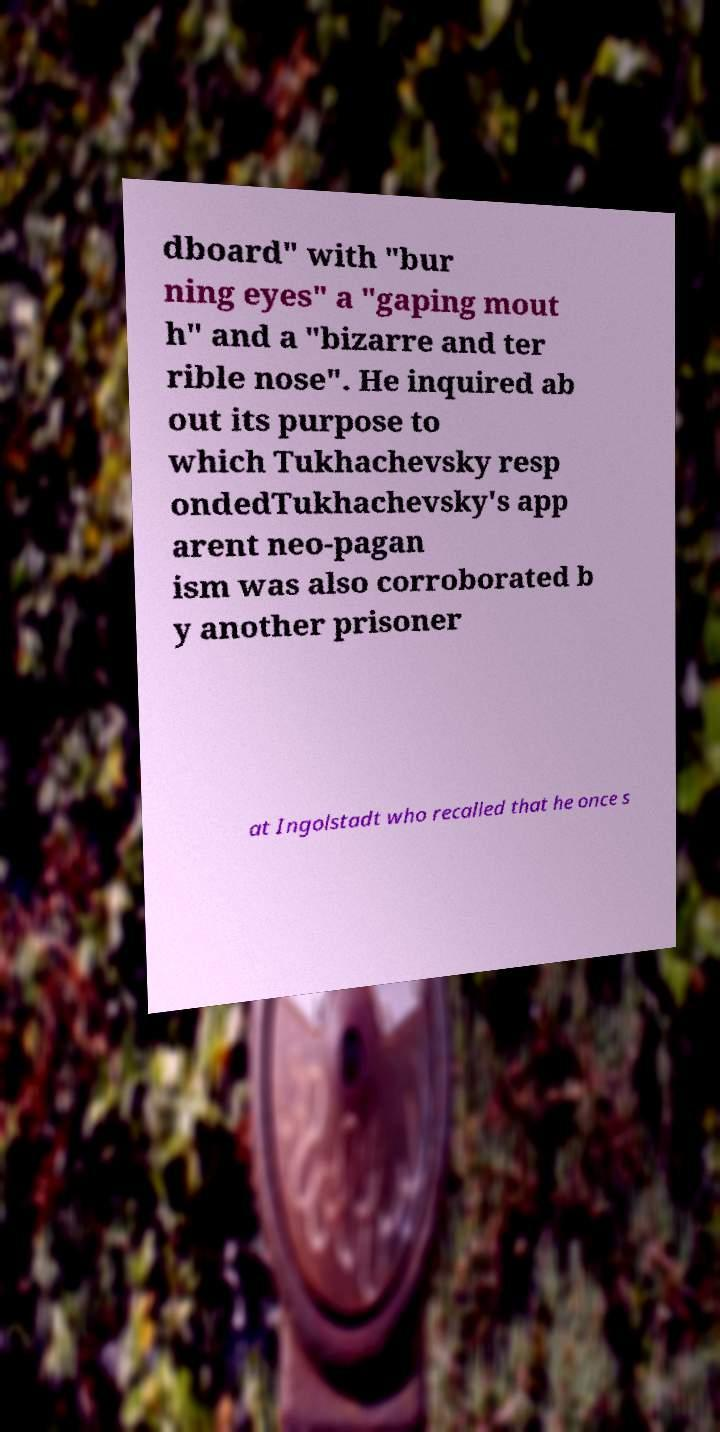There's text embedded in this image that I need extracted. Can you transcribe it verbatim? dboard" with "bur ning eyes" a "gaping mout h" and a "bizarre and ter rible nose". He inquired ab out its purpose to which Tukhachevsky resp ondedTukhachevsky's app arent neo-pagan ism was also corroborated b y another prisoner at Ingolstadt who recalled that he once s 